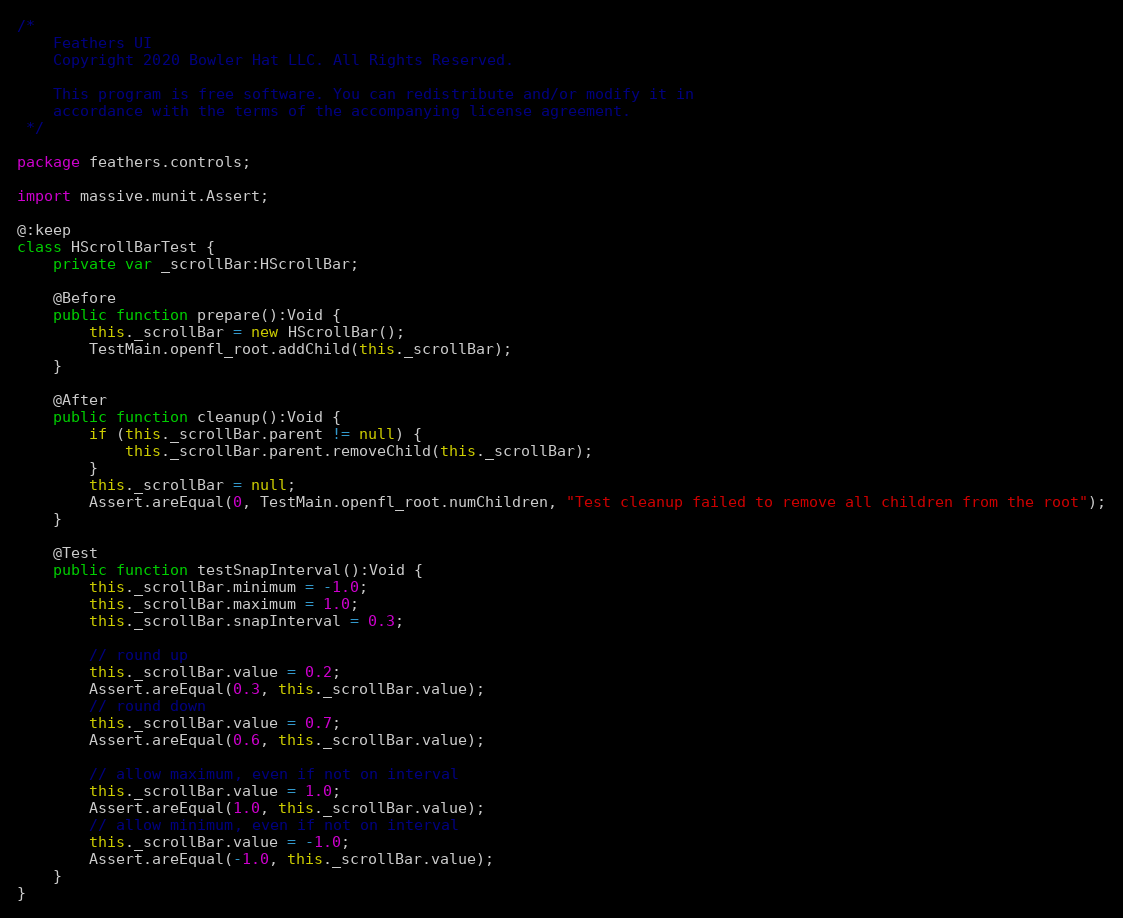Convert code to text. <code><loc_0><loc_0><loc_500><loc_500><_Haxe_>/*
	Feathers UI
	Copyright 2020 Bowler Hat LLC. All Rights Reserved.

	This program is free software. You can redistribute and/or modify it in
	accordance with the terms of the accompanying license agreement.
 */

package feathers.controls;

import massive.munit.Assert;

@:keep
class HScrollBarTest {
	private var _scrollBar:HScrollBar;

	@Before
	public function prepare():Void {
		this._scrollBar = new HScrollBar();
		TestMain.openfl_root.addChild(this._scrollBar);
	}

	@After
	public function cleanup():Void {
		if (this._scrollBar.parent != null) {
			this._scrollBar.parent.removeChild(this._scrollBar);
		}
		this._scrollBar = null;
		Assert.areEqual(0, TestMain.openfl_root.numChildren, "Test cleanup failed to remove all children from the root");
	}

	@Test
	public function testSnapInterval():Void {
		this._scrollBar.minimum = -1.0;
		this._scrollBar.maximum = 1.0;
		this._scrollBar.snapInterval = 0.3;

		// round up
		this._scrollBar.value = 0.2;
		Assert.areEqual(0.3, this._scrollBar.value);
		// round down
		this._scrollBar.value = 0.7;
		Assert.areEqual(0.6, this._scrollBar.value);

		// allow maximum, even if not on interval
		this._scrollBar.value = 1.0;
		Assert.areEqual(1.0, this._scrollBar.value);
		// allow minimum, even if not on interval
		this._scrollBar.value = -1.0;
		Assert.areEqual(-1.0, this._scrollBar.value);
	}
}
</code> 